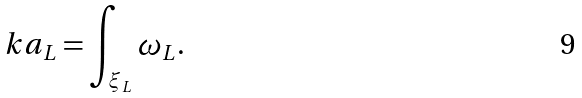<formula> <loc_0><loc_0><loc_500><loc_500>\ k a _ { L } = \int _ { \xi _ { L } } \omega _ { L } .</formula> 